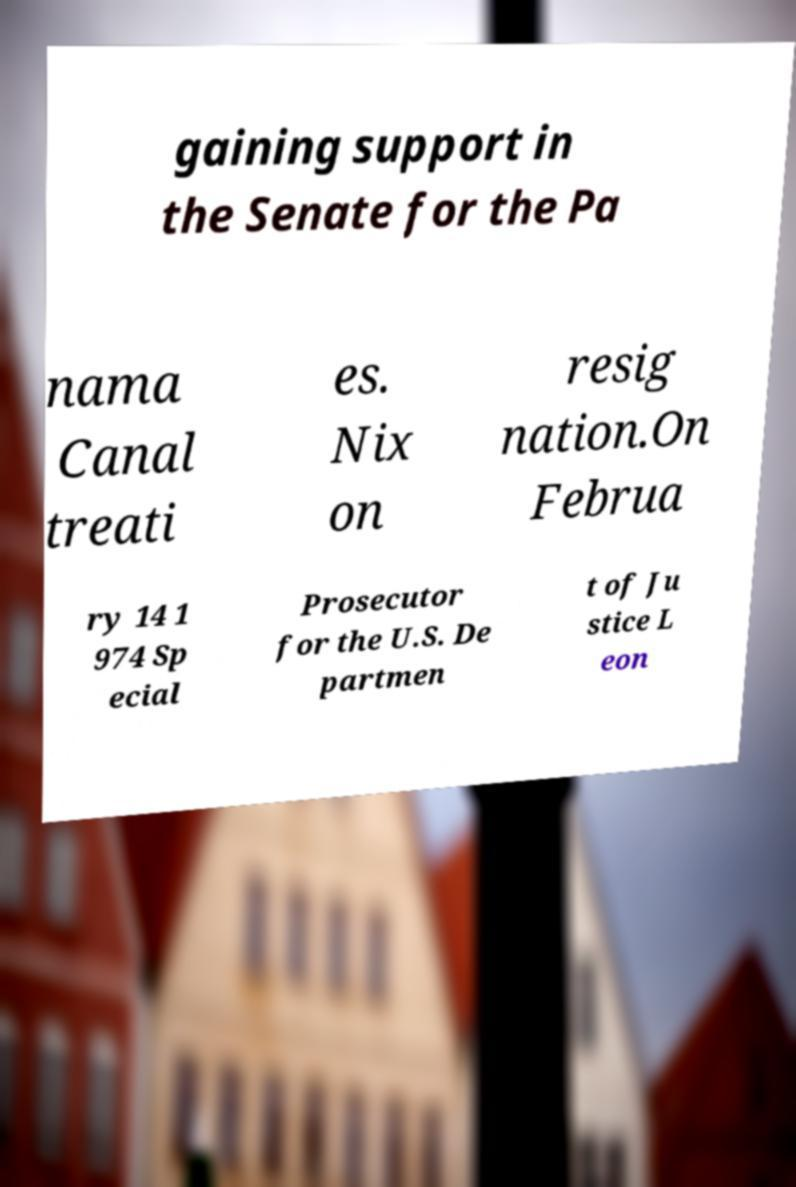I need the written content from this picture converted into text. Can you do that? gaining support in the Senate for the Pa nama Canal treati es. Nix on resig nation.On Februa ry 14 1 974 Sp ecial Prosecutor for the U.S. De partmen t of Ju stice L eon 